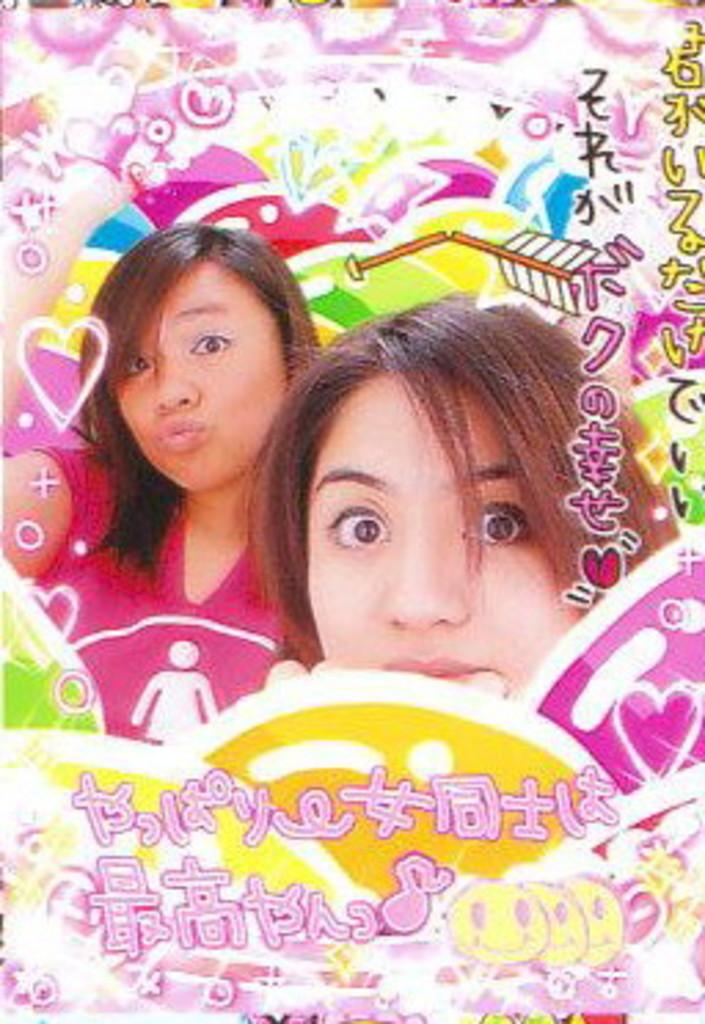What type of picture is present in the image? The image contains an edited picture. Can you describe the edited picture? The edited picture has a design and text. How many people are in the image? There are two persons in the image. What type of celery is being advertised in the image? There is no celery or advertisement present in the image. What kind of marble is visible in the image? There is no marble visible in the image. 